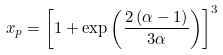Convert formula to latex. <formula><loc_0><loc_0><loc_500><loc_500>x _ { p } = \left [ 1 + \exp \left ( \frac { 2 \left ( \alpha - 1 \right ) } { 3 \alpha } \right ) \right ] ^ { 3 }</formula> 